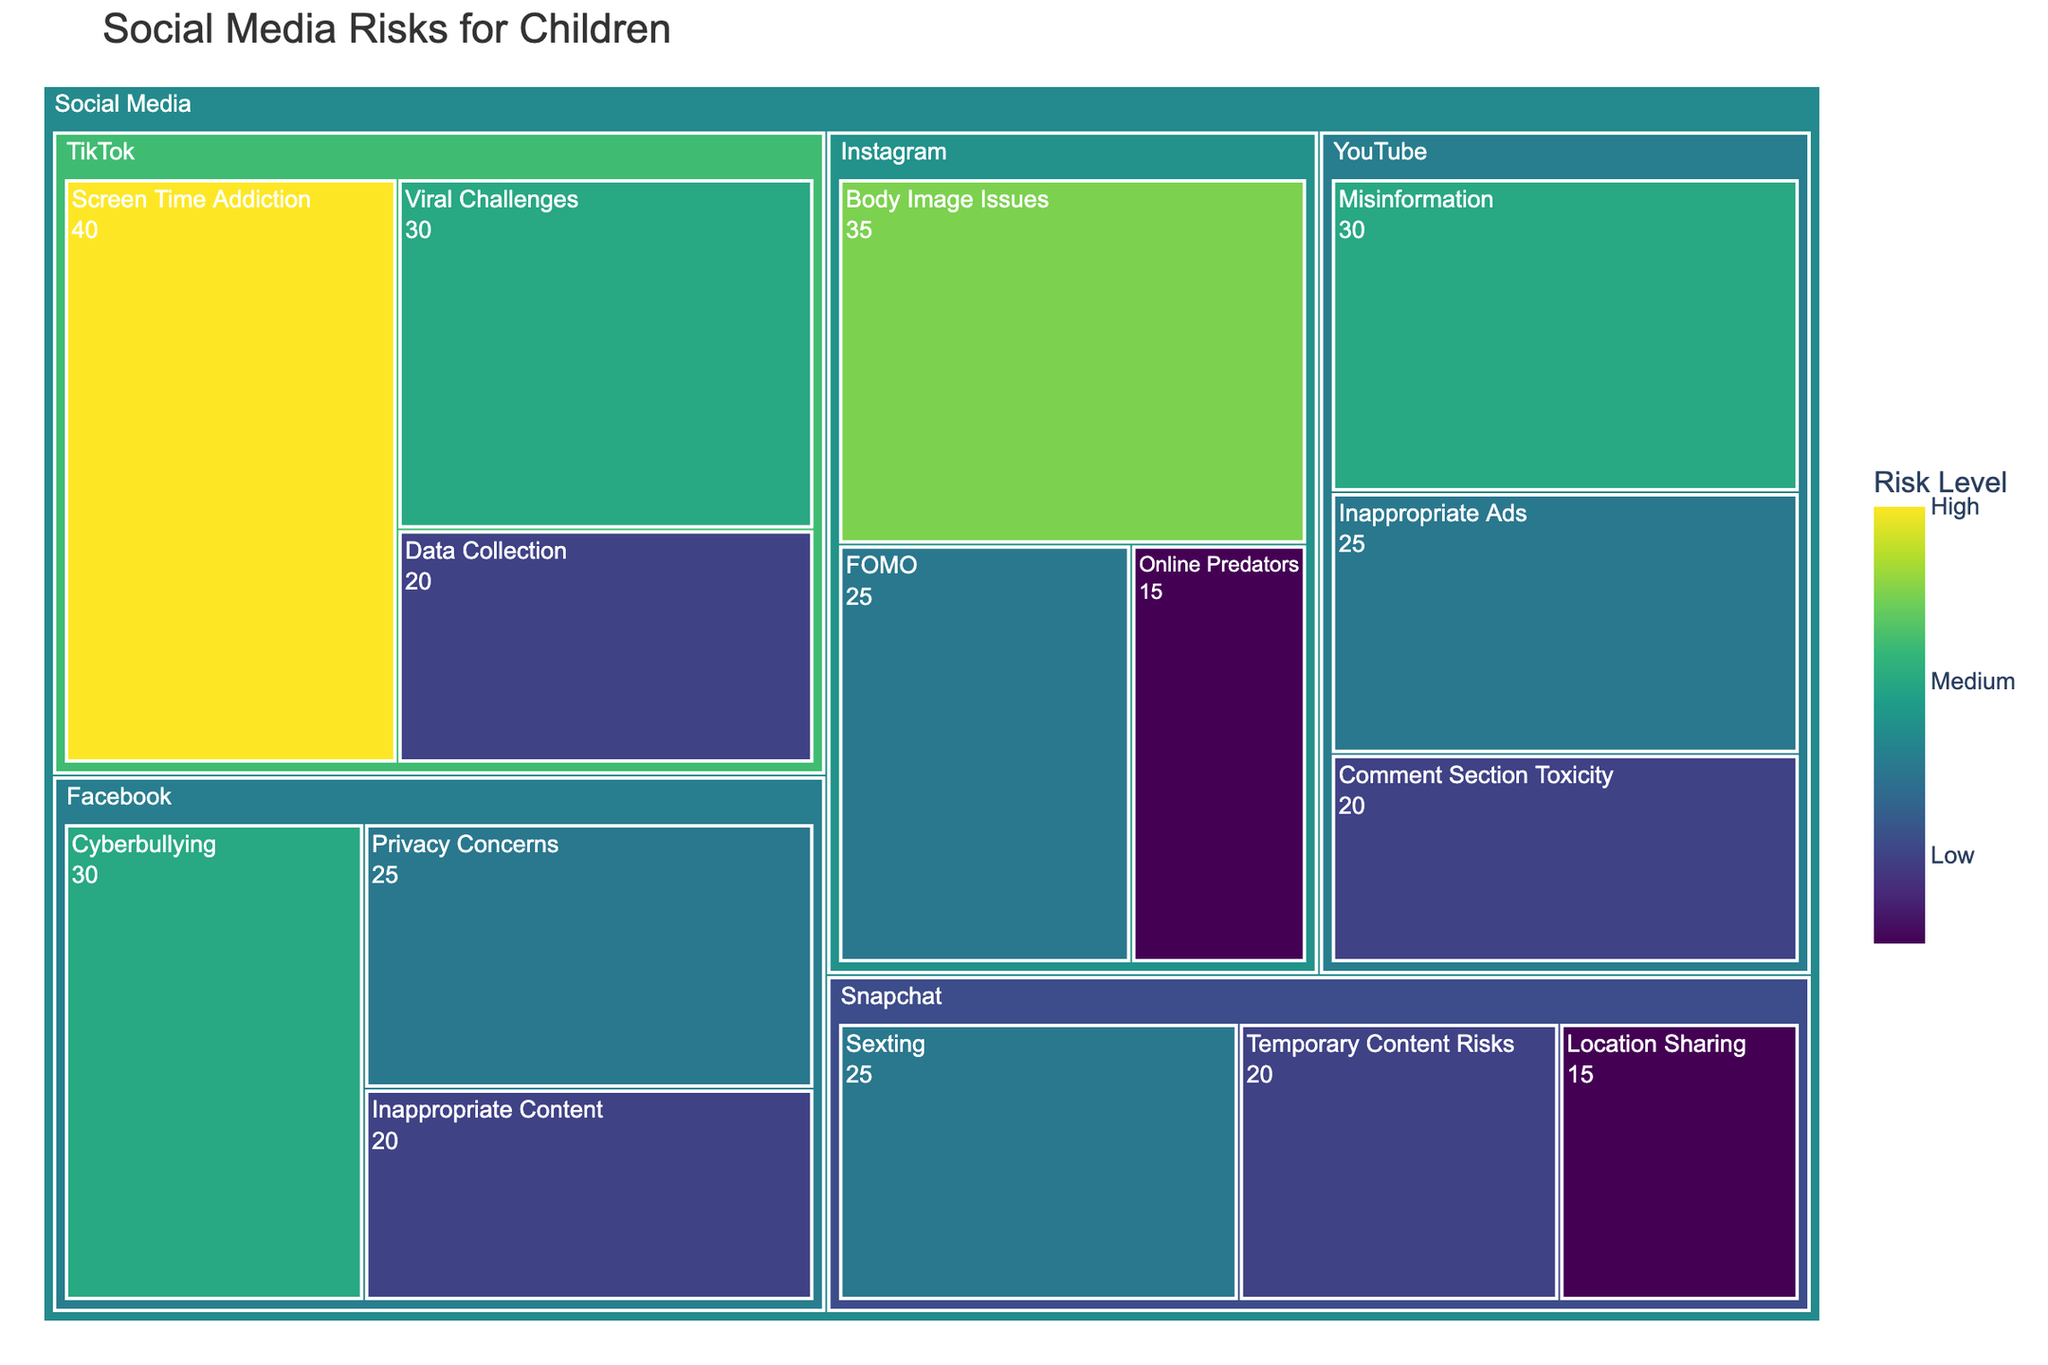What is the title of the treemap? The title of the treemap is usually displayed prominently at the top of the figure. It's designed to give a quick overview of what the chart is about.
Answer: Social Media Risks for Children Which subcategory under Facebook has the highest risk level? To determine this, look under the Facebook section for subcategories and compare their values. The subcategory with the highest value has the highest risk level.
Answer: Cyberbullying How does the risk level of 'Body Image Issues' on Instagram compare to 'Sexting' on Snapchat? Locate the sections for Instagram and Snapchat. Identify the subcategories 'Body Image Issues' and 'Sexting' and compare their values. 'Body Image Issues' has a value of 35, while 'Sexting' has a value of 25.
Answer: Body Image Issues has a higher risk level than Sexting Which subcategory has the lowest risk level under the TikTok platform? Identify and compare the values of all subcategories under TikTok. The subcategory with the lowest value has the lowest risk level.
Answer: Online Predators Which social media platform has the highest total risk level? Add up the values of all subcategories under each platform and compare the totals. The platform with the highest total is the one with the highest risk level. Calculate as follows:
- Facebook: 30 + 25 + 20 = 75
- Instagram: 35 + 25 + 15 = 75
- TikTok: 40 + 30 + 20 = 90
- Snapchat: 25 + 20 + 15 = 60
- YouTube: 30 + 25 + 20 = 75
Answer: TikTok has the highest total risk level Is the risk level of 'Data Collection' on TikTok higher or lower than the risk level of 'Temporary Content Risks' on Snapchat? Compare the values of 'Data Collection' on TikTok (20) with 'Temporary Content Risks' on Snapchat (20).
Answer: Equal Which subcategory related to Instagram has the second highest risk level? Identify and list the risk levels of all subcategories under Instagram: Body Image Issues (35), FOMO (25), Online Predators (15), then identify the second highest value.
Answer: FOMO 